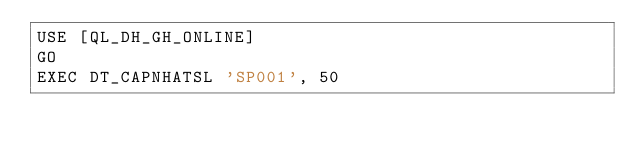Convert code to text. <code><loc_0><loc_0><loc_500><loc_500><_SQL_>USE [QL_DH_GH_ONLINE]
GO
EXEC DT_CAPNHATSL 'SP001', 50</code> 